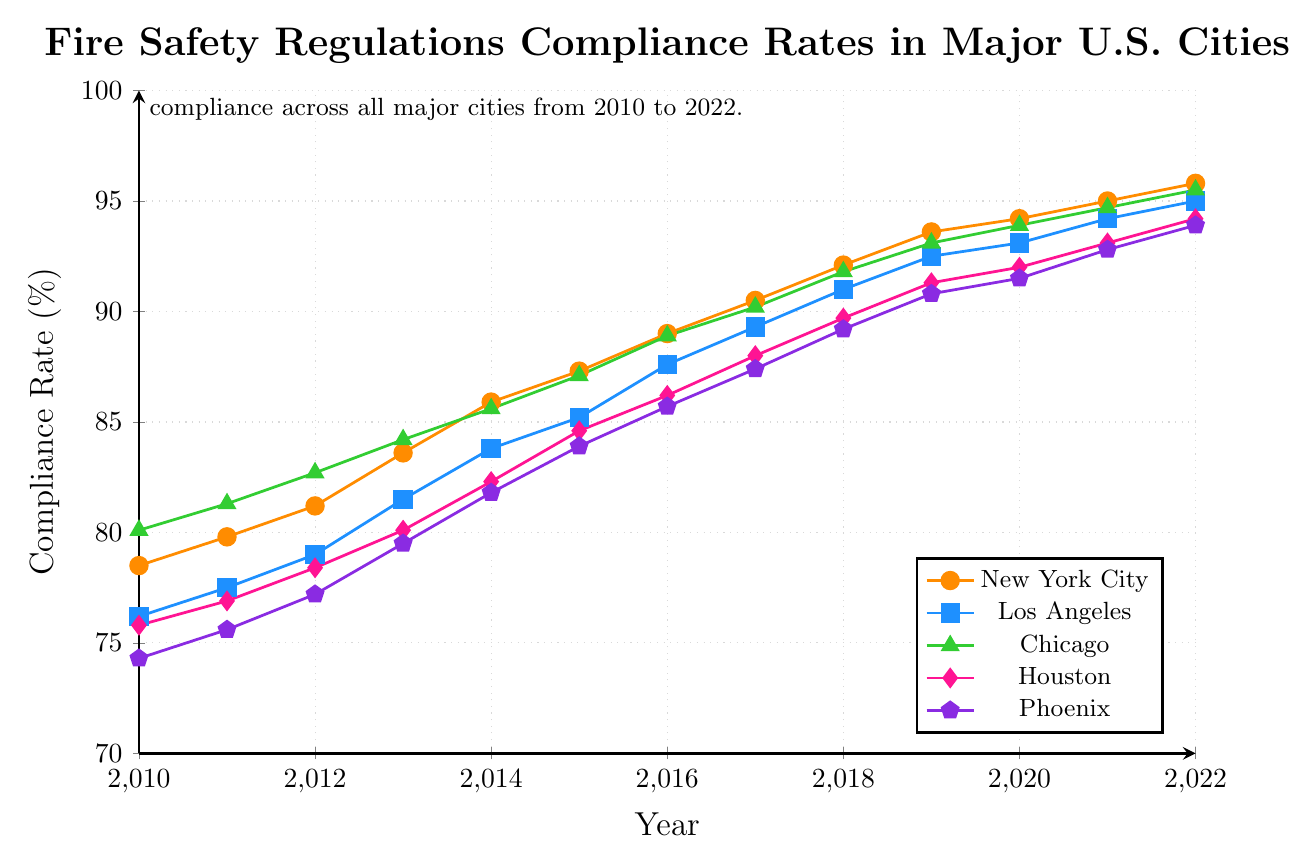What is the compliance rate of New York City in 2022? Locate the line for New York City on the graph and find the data point corresponding to the year 2022. The compliance rate is 95.8%.
Answer: 95.8% Which city had the lowest compliance rate in 2010? Compare the data points for all cities in 2010. The lowest value is for Phoenix with 74.3%.
Answer: Phoenix What is the average compliance rate of Los Angeles from 2010 to 2022? Add up the compliance rates for Los Angeles from 2010 to 2022 and divide by the number of years. (76.2 + 77.5 + 79.0 + 81.5 + 83.8 + 85.2 + 87.6 + 89.3 + 91.0 + 92.5 + 93.1 + 94.2 + 95.0) / 13 = 86.4%
Answer: 86.4% Which city showed the greatest improvement in compliance rate from 2010 to 2022? Subtract the 2010 compliance rate from the 2022 compliance rate for each city and identify the city with the highest difference. New York City improved from 78.5% to 95.8%, a difference of 17.3%. The other differences are 18.8% for LA, 15.4% for Chicago, 18.4% for Houston, and 19.6% for Phoenix.
Answer: Phoenix In which year did Houston's compliance rate exceed 85%? Identify the year when the compliance rate for Houston crosses the 85% mark. This occurred in 2016 when it reached 86.2%.
Answer: 2016 Which two cities had the closest compliance rates in 2015? Compare the compliance rates of all cities in 2015. Los Angeles (85.2%) and Phoenix (83.9%) are the closest with a difference of 1.3%.
Answer: Los Angeles and Phoenix Did any city's compliance rate decrease in any year? Examine the trends for all cities from year to year. No city's compliance rate decreased in any year; all rates consistently increased.
Answer: No What is the difference in compliance rates between Chicago and Phoenix in 2022? Find the data points for both cities in 2022 and subtract Phoenix's rate from Chicago's rate. 95.5% - 93.9% = 1.6%
Answer: 1.6% How many cities had a compliance rate above 90% in 2020? Check the compliance rates for all cities in 2020. Four cities (New York City, Los Angeles, Chicago, and Houston) had rates above 90%.
Answer: Four 